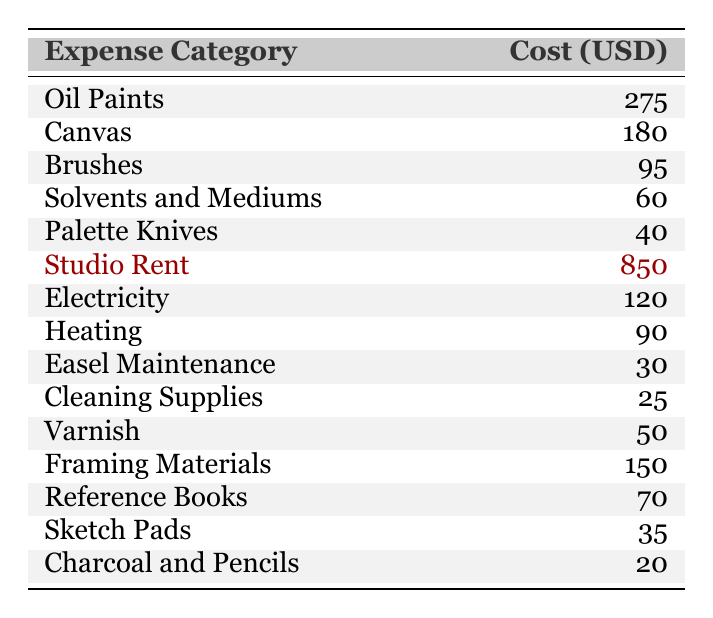What is the total cost of the art supplies? To find the total cost, we need to sum all the values in the "Cost (USD)" column for art supplies: 275 + 180 + 95 + 60 + 40 + 50 + 150 + 70 + 35 + 20 = 1,000.
Answer: 1000 How much does Studio Rent cost? From the table, the cost of Studio Rent is explicitly stated in the "Cost (USD)" column: 850.
Answer: 850 Is the cost for Brushes greater than that for Charcoal and Pencils? The cost for Brushes is 95, while that for Charcoal and Pencils is 20. Since 95 is greater than 20, the statement is true.
Answer: Yes What is the average cost of Cleaning Supplies and Easel Maintenance? To find the average, we first need the total cost of Cleaning Supplies (25) and Easel Maintenance (30). The sum is 25 + 30 = 55. Then, we divide by 2 (the number of items): 55 / 2 = 27.5.
Answer: 27.5 Which expense category has the highest cost? By reviewing the table, we can see that the category with the highest cost in "Cost (USD)" is Studio Rent at 850.
Answer: Studio Rent What is the difference in cost between Canvas and Oil Paints? The cost of Canvas is 180 and the cost of Oil Paints is 275. The difference is calculated as 275 - 180 = 95.
Answer: 95 Are Reference Books more expensive than Varnish? Reference Books cost 70 and Varnish costs 50. Since 70 is greater than 50, the statement is true.
Answer: Yes What is the total cost of Electricity and Heating? The cost of Electricity is 120 and the cost of Heating is 90. Adding these together gives us 120 + 90 = 210.
Answer: 210 What is the median cost of all expenses listed? First, we list the costs in ascending order: 20 (Charcoal and Pencils), 25 (Cleaning Supplies), 30 (Easel Maintenance), 35 (Sketch Pads), 40 (Palette Knives), 50 (Varnish), 60 (Solvents and Mediums), 70 (Reference Books), 90 (Heating), 95 (Brushes), 150 (Framing Materials), 180 (Canvas), 275 (Oil Paints), 850 (Studio Rent). There are 14 values, thus the median is the average of the 7th and 8th values in this ordered list: (60 + 70) / 2 = 65.
Answer: 65 